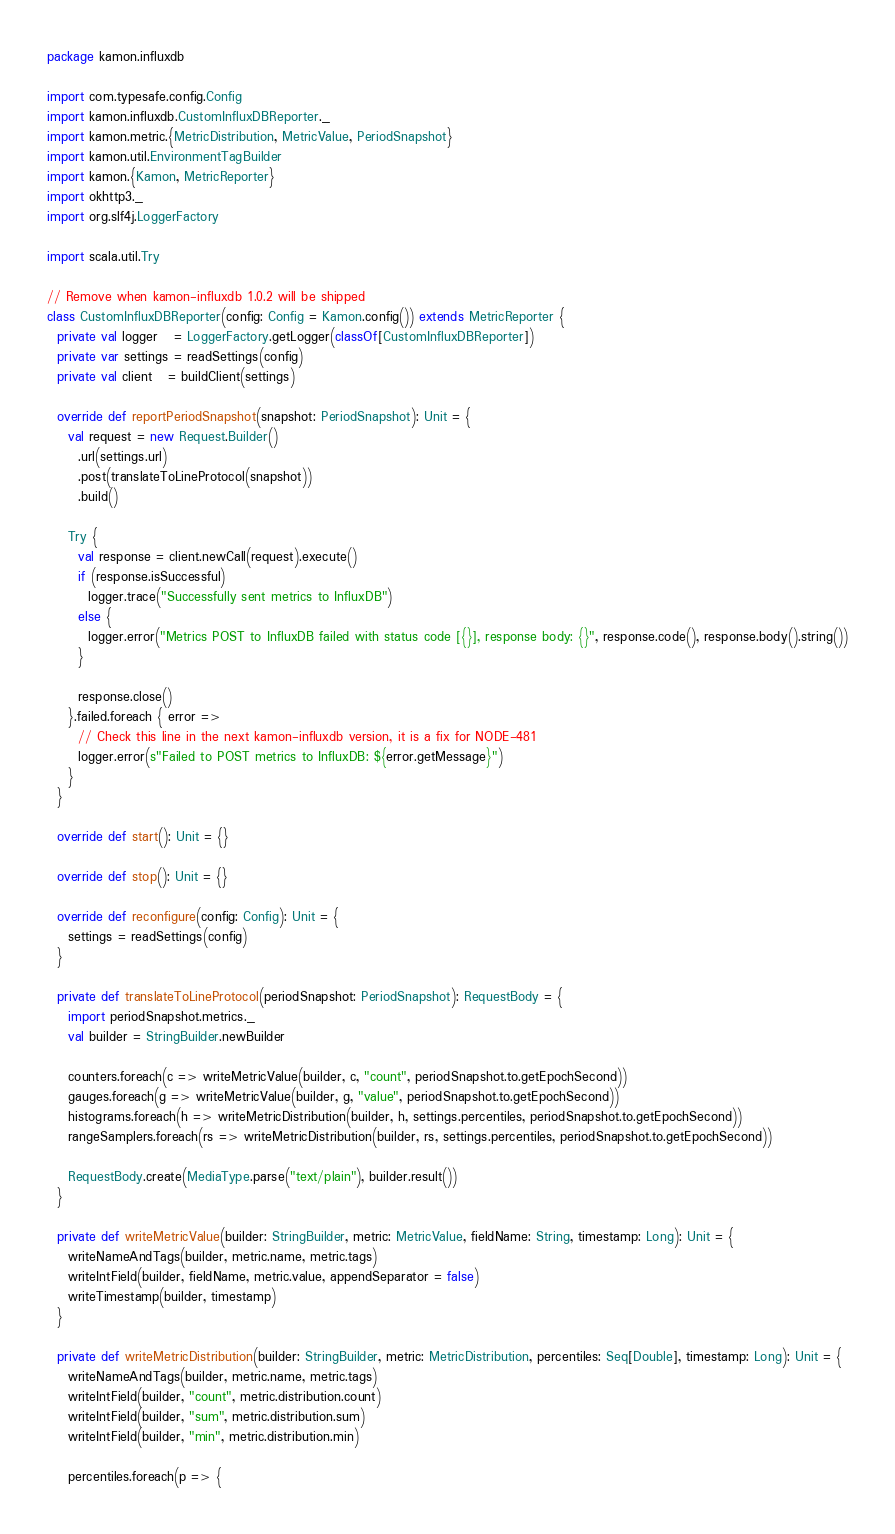<code> <loc_0><loc_0><loc_500><loc_500><_Scala_>package kamon.influxdb

import com.typesafe.config.Config
import kamon.influxdb.CustomInfluxDBReporter._
import kamon.metric.{MetricDistribution, MetricValue, PeriodSnapshot}
import kamon.util.EnvironmentTagBuilder
import kamon.{Kamon, MetricReporter}
import okhttp3._
import org.slf4j.LoggerFactory

import scala.util.Try

// Remove when kamon-influxdb 1.0.2 will be shipped
class CustomInfluxDBReporter(config: Config = Kamon.config()) extends MetricReporter {
  private val logger   = LoggerFactory.getLogger(classOf[CustomInfluxDBReporter])
  private var settings = readSettings(config)
  private val client   = buildClient(settings)

  override def reportPeriodSnapshot(snapshot: PeriodSnapshot): Unit = {
    val request = new Request.Builder()
      .url(settings.url)
      .post(translateToLineProtocol(snapshot))
      .build()

    Try {
      val response = client.newCall(request).execute()
      if (response.isSuccessful)
        logger.trace("Successfully sent metrics to InfluxDB")
      else {
        logger.error("Metrics POST to InfluxDB failed with status code [{}], response body: {}", response.code(), response.body().string())
      }

      response.close()
    }.failed.foreach { error =>
      // Check this line in the next kamon-influxdb version, it is a fix for NODE-481
      logger.error(s"Failed to POST metrics to InfluxDB: ${error.getMessage}")
    }
  }

  override def start(): Unit = {}

  override def stop(): Unit = {}

  override def reconfigure(config: Config): Unit = {
    settings = readSettings(config)
  }

  private def translateToLineProtocol(periodSnapshot: PeriodSnapshot): RequestBody = {
    import periodSnapshot.metrics._
    val builder = StringBuilder.newBuilder

    counters.foreach(c => writeMetricValue(builder, c, "count", periodSnapshot.to.getEpochSecond))
    gauges.foreach(g => writeMetricValue(builder, g, "value", periodSnapshot.to.getEpochSecond))
    histograms.foreach(h => writeMetricDistribution(builder, h, settings.percentiles, periodSnapshot.to.getEpochSecond))
    rangeSamplers.foreach(rs => writeMetricDistribution(builder, rs, settings.percentiles, periodSnapshot.to.getEpochSecond))

    RequestBody.create(MediaType.parse("text/plain"), builder.result())
  }

  private def writeMetricValue(builder: StringBuilder, metric: MetricValue, fieldName: String, timestamp: Long): Unit = {
    writeNameAndTags(builder, metric.name, metric.tags)
    writeIntField(builder, fieldName, metric.value, appendSeparator = false)
    writeTimestamp(builder, timestamp)
  }

  private def writeMetricDistribution(builder: StringBuilder, metric: MetricDistribution, percentiles: Seq[Double], timestamp: Long): Unit = {
    writeNameAndTags(builder, metric.name, metric.tags)
    writeIntField(builder, "count", metric.distribution.count)
    writeIntField(builder, "sum", metric.distribution.sum)
    writeIntField(builder, "min", metric.distribution.min)

    percentiles.foreach(p => {</code> 